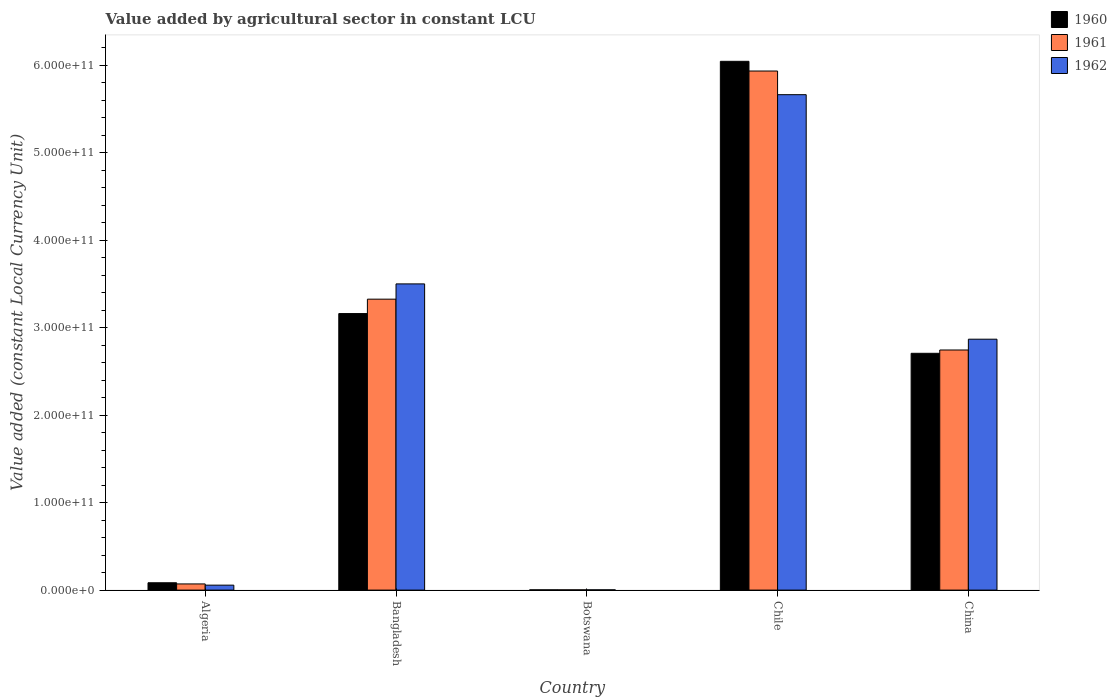Are the number of bars per tick equal to the number of legend labels?
Provide a short and direct response. Yes. Are the number of bars on each tick of the X-axis equal?
Your response must be concise. Yes. How many bars are there on the 2nd tick from the right?
Provide a succinct answer. 3. What is the label of the 1st group of bars from the left?
Your response must be concise. Algeria. In how many cases, is the number of bars for a given country not equal to the number of legend labels?
Provide a succinct answer. 0. What is the value added by agricultural sector in 1962 in Chile?
Give a very brief answer. 5.67e+11. Across all countries, what is the maximum value added by agricultural sector in 1960?
Your answer should be very brief. 6.05e+11. Across all countries, what is the minimum value added by agricultural sector in 1962?
Offer a terse response. 2.96e+08. In which country was the value added by agricultural sector in 1961 maximum?
Your response must be concise. Chile. In which country was the value added by agricultural sector in 1962 minimum?
Offer a terse response. Botswana. What is the total value added by agricultural sector in 1961 in the graph?
Your response must be concise. 1.21e+12. What is the difference between the value added by agricultural sector in 1960 in Algeria and that in Bangladesh?
Your answer should be very brief. -3.08e+11. What is the difference between the value added by agricultural sector in 1960 in Chile and the value added by agricultural sector in 1962 in China?
Your response must be concise. 3.18e+11. What is the average value added by agricultural sector in 1962 per country?
Offer a terse response. 2.42e+11. What is the difference between the value added by agricultural sector of/in 1960 and value added by agricultural sector of/in 1961 in Botswana?
Provide a succinct answer. -6.88e+06. In how many countries, is the value added by agricultural sector in 1960 greater than 280000000000 LCU?
Your answer should be compact. 2. What is the ratio of the value added by agricultural sector in 1960 in Algeria to that in Botswana?
Your answer should be very brief. 30.08. Is the difference between the value added by agricultural sector in 1960 in Bangladesh and Chile greater than the difference between the value added by agricultural sector in 1961 in Bangladesh and Chile?
Give a very brief answer. No. What is the difference between the highest and the second highest value added by agricultural sector in 1962?
Provide a short and direct response. -2.16e+11. What is the difference between the highest and the lowest value added by agricultural sector in 1960?
Provide a short and direct response. 6.04e+11. What does the 1st bar from the left in Chile represents?
Make the answer very short. 1960. Is it the case that in every country, the sum of the value added by agricultural sector in 1962 and value added by agricultural sector in 1960 is greater than the value added by agricultural sector in 1961?
Offer a terse response. Yes. Are all the bars in the graph horizontal?
Ensure brevity in your answer.  No. What is the difference between two consecutive major ticks on the Y-axis?
Offer a terse response. 1.00e+11. Does the graph contain any zero values?
Offer a terse response. No. Where does the legend appear in the graph?
Your response must be concise. Top right. What is the title of the graph?
Provide a short and direct response. Value added by agricultural sector in constant LCU. What is the label or title of the Y-axis?
Give a very brief answer. Value added (constant Local Currency Unit). What is the Value added (constant Local Currency Unit) of 1960 in Algeria?
Ensure brevity in your answer.  8.40e+09. What is the Value added (constant Local Currency Unit) of 1961 in Algeria?
Make the answer very short. 7.05e+09. What is the Value added (constant Local Currency Unit) of 1962 in Algeria?
Your answer should be very brief. 5.66e+09. What is the Value added (constant Local Currency Unit) of 1960 in Bangladesh?
Provide a short and direct response. 3.16e+11. What is the Value added (constant Local Currency Unit) of 1961 in Bangladesh?
Your answer should be compact. 3.33e+11. What is the Value added (constant Local Currency Unit) of 1962 in Bangladesh?
Your answer should be very brief. 3.50e+11. What is the Value added (constant Local Currency Unit) in 1960 in Botswana?
Offer a terse response. 2.79e+08. What is the Value added (constant Local Currency Unit) in 1961 in Botswana?
Provide a short and direct response. 2.86e+08. What is the Value added (constant Local Currency Unit) in 1962 in Botswana?
Provide a succinct answer. 2.96e+08. What is the Value added (constant Local Currency Unit) of 1960 in Chile?
Ensure brevity in your answer.  6.05e+11. What is the Value added (constant Local Currency Unit) of 1961 in Chile?
Your answer should be very brief. 5.94e+11. What is the Value added (constant Local Currency Unit) in 1962 in Chile?
Provide a succinct answer. 5.67e+11. What is the Value added (constant Local Currency Unit) in 1960 in China?
Offer a very short reply. 2.71e+11. What is the Value added (constant Local Currency Unit) of 1961 in China?
Your response must be concise. 2.75e+11. What is the Value added (constant Local Currency Unit) in 1962 in China?
Ensure brevity in your answer.  2.87e+11. Across all countries, what is the maximum Value added (constant Local Currency Unit) in 1960?
Keep it short and to the point. 6.05e+11. Across all countries, what is the maximum Value added (constant Local Currency Unit) of 1961?
Your answer should be very brief. 5.94e+11. Across all countries, what is the maximum Value added (constant Local Currency Unit) in 1962?
Offer a terse response. 5.67e+11. Across all countries, what is the minimum Value added (constant Local Currency Unit) in 1960?
Offer a terse response. 2.79e+08. Across all countries, what is the minimum Value added (constant Local Currency Unit) in 1961?
Offer a terse response. 2.86e+08. Across all countries, what is the minimum Value added (constant Local Currency Unit) of 1962?
Provide a succinct answer. 2.96e+08. What is the total Value added (constant Local Currency Unit) in 1960 in the graph?
Your answer should be compact. 1.20e+12. What is the total Value added (constant Local Currency Unit) of 1961 in the graph?
Keep it short and to the point. 1.21e+12. What is the total Value added (constant Local Currency Unit) in 1962 in the graph?
Your answer should be compact. 1.21e+12. What is the difference between the Value added (constant Local Currency Unit) in 1960 in Algeria and that in Bangladesh?
Offer a very short reply. -3.08e+11. What is the difference between the Value added (constant Local Currency Unit) of 1961 in Algeria and that in Bangladesh?
Offer a very short reply. -3.26e+11. What is the difference between the Value added (constant Local Currency Unit) of 1962 in Algeria and that in Bangladesh?
Give a very brief answer. -3.44e+11. What is the difference between the Value added (constant Local Currency Unit) in 1960 in Algeria and that in Botswana?
Offer a very short reply. 8.12e+09. What is the difference between the Value added (constant Local Currency Unit) of 1961 in Algeria and that in Botswana?
Offer a terse response. 6.77e+09. What is the difference between the Value added (constant Local Currency Unit) in 1962 in Algeria and that in Botswana?
Provide a succinct answer. 5.36e+09. What is the difference between the Value added (constant Local Currency Unit) of 1960 in Algeria and that in Chile?
Make the answer very short. -5.96e+11. What is the difference between the Value added (constant Local Currency Unit) in 1961 in Algeria and that in Chile?
Offer a very short reply. -5.87e+11. What is the difference between the Value added (constant Local Currency Unit) in 1962 in Algeria and that in Chile?
Your answer should be compact. -5.61e+11. What is the difference between the Value added (constant Local Currency Unit) in 1960 in Algeria and that in China?
Ensure brevity in your answer.  -2.62e+11. What is the difference between the Value added (constant Local Currency Unit) in 1961 in Algeria and that in China?
Your answer should be very brief. -2.68e+11. What is the difference between the Value added (constant Local Currency Unit) of 1962 in Algeria and that in China?
Keep it short and to the point. -2.81e+11. What is the difference between the Value added (constant Local Currency Unit) in 1960 in Bangladesh and that in Botswana?
Keep it short and to the point. 3.16e+11. What is the difference between the Value added (constant Local Currency Unit) of 1961 in Bangladesh and that in Botswana?
Provide a short and direct response. 3.32e+11. What is the difference between the Value added (constant Local Currency Unit) of 1962 in Bangladesh and that in Botswana?
Your answer should be compact. 3.50e+11. What is the difference between the Value added (constant Local Currency Unit) of 1960 in Bangladesh and that in Chile?
Offer a terse response. -2.88e+11. What is the difference between the Value added (constant Local Currency Unit) in 1961 in Bangladesh and that in Chile?
Offer a terse response. -2.61e+11. What is the difference between the Value added (constant Local Currency Unit) in 1962 in Bangladesh and that in Chile?
Your answer should be compact. -2.16e+11. What is the difference between the Value added (constant Local Currency Unit) in 1960 in Bangladesh and that in China?
Make the answer very short. 4.54e+1. What is the difference between the Value added (constant Local Currency Unit) of 1961 in Bangladesh and that in China?
Make the answer very short. 5.81e+1. What is the difference between the Value added (constant Local Currency Unit) in 1962 in Bangladesh and that in China?
Provide a short and direct response. 6.32e+1. What is the difference between the Value added (constant Local Currency Unit) in 1960 in Botswana and that in Chile?
Your response must be concise. -6.04e+11. What is the difference between the Value added (constant Local Currency Unit) in 1961 in Botswana and that in Chile?
Offer a very short reply. -5.93e+11. What is the difference between the Value added (constant Local Currency Unit) of 1962 in Botswana and that in Chile?
Give a very brief answer. -5.66e+11. What is the difference between the Value added (constant Local Currency Unit) of 1960 in Botswana and that in China?
Offer a very short reply. -2.70e+11. What is the difference between the Value added (constant Local Currency Unit) in 1961 in Botswana and that in China?
Offer a very short reply. -2.74e+11. What is the difference between the Value added (constant Local Currency Unit) in 1962 in Botswana and that in China?
Keep it short and to the point. -2.87e+11. What is the difference between the Value added (constant Local Currency Unit) in 1960 in Chile and that in China?
Offer a very short reply. 3.34e+11. What is the difference between the Value added (constant Local Currency Unit) in 1961 in Chile and that in China?
Give a very brief answer. 3.19e+11. What is the difference between the Value added (constant Local Currency Unit) of 1962 in Chile and that in China?
Make the answer very short. 2.80e+11. What is the difference between the Value added (constant Local Currency Unit) of 1960 in Algeria and the Value added (constant Local Currency Unit) of 1961 in Bangladesh?
Make the answer very short. -3.24e+11. What is the difference between the Value added (constant Local Currency Unit) in 1960 in Algeria and the Value added (constant Local Currency Unit) in 1962 in Bangladesh?
Provide a succinct answer. -3.42e+11. What is the difference between the Value added (constant Local Currency Unit) in 1961 in Algeria and the Value added (constant Local Currency Unit) in 1962 in Bangladesh?
Ensure brevity in your answer.  -3.43e+11. What is the difference between the Value added (constant Local Currency Unit) in 1960 in Algeria and the Value added (constant Local Currency Unit) in 1961 in Botswana?
Your answer should be very brief. 8.11e+09. What is the difference between the Value added (constant Local Currency Unit) of 1960 in Algeria and the Value added (constant Local Currency Unit) of 1962 in Botswana?
Keep it short and to the point. 8.10e+09. What is the difference between the Value added (constant Local Currency Unit) of 1961 in Algeria and the Value added (constant Local Currency Unit) of 1962 in Botswana?
Provide a short and direct response. 6.76e+09. What is the difference between the Value added (constant Local Currency Unit) in 1960 in Algeria and the Value added (constant Local Currency Unit) in 1961 in Chile?
Provide a short and direct response. -5.85e+11. What is the difference between the Value added (constant Local Currency Unit) in 1960 in Algeria and the Value added (constant Local Currency Unit) in 1962 in Chile?
Provide a short and direct response. -5.58e+11. What is the difference between the Value added (constant Local Currency Unit) of 1961 in Algeria and the Value added (constant Local Currency Unit) of 1962 in Chile?
Ensure brevity in your answer.  -5.59e+11. What is the difference between the Value added (constant Local Currency Unit) of 1960 in Algeria and the Value added (constant Local Currency Unit) of 1961 in China?
Your answer should be very brief. -2.66e+11. What is the difference between the Value added (constant Local Currency Unit) of 1960 in Algeria and the Value added (constant Local Currency Unit) of 1962 in China?
Your response must be concise. -2.79e+11. What is the difference between the Value added (constant Local Currency Unit) of 1961 in Algeria and the Value added (constant Local Currency Unit) of 1962 in China?
Offer a very short reply. -2.80e+11. What is the difference between the Value added (constant Local Currency Unit) in 1960 in Bangladesh and the Value added (constant Local Currency Unit) in 1961 in Botswana?
Provide a short and direct response. 3.16e+11. What is the difference between the Value added (constant Local Currency Unit) of 1960 in Bangladesh and the Value added (constant Local Currency Unit) of 1962 in Botswana?
Keep it short and to the point. 3.16e+11. What is the difference between the Value added (constant Local Currency Unit) in 1961 in Bangladesh and the Value added (constant Local Currency Unit) in 1962 in Botswana?
Offer a terse response. 3.32e+11. What is the difference between the Value added (constant Local Currency Unit) in 1960 in Bangladesh and the Value added (constant Local Currency Unit) in 1961 in Chile?
Your answer should be compact. -2.77e+11. What is the difference between the Value added (constant Local Currency Unit) in 1960 in Bangladesh and the Value added (constant Local Currency Unit) in 1962 in Chile?
Make the answer very short. -2.50e+11. What is the difference between the Value added (constant Local Currency Unit) in 1961 in Bangladesh and the Value added (constant Local Currency Unit) in 1962 in Chile?
Offer a very short reply. -2.34e+11. What is the difference between the Value added (constant Local Currency Unit) of 1960 in Bangladesh and the Value added (constant Local Currency Unit) of 1961 in China?
Your response must be concise. 4.17e+1. What is the difference between the Value added (constant Local Currency Unit) in 1960 in Bangladesh and the Value added (constant Local Currency Unit) in 1962 in China?
Ensure brevity in your answer.  2.93e+1. What is the difference between the Value added (constant Local Currency Unit) in 1961 in Bangladesh and the Value added (constant Local Currency Unit) in 1962 in China?
Your response must be concise. 4.58e+1. What is the difference between the Value added (constant Local Currency Unit) of 1960 in Botswana and the Value added (constant Local Currency Unit) of 1961 in Chile?
Give a very brief answer. -5.93e+11. What is the difference between the Value added (constant Local Currency Unit) in 1960 in Botswana and the Value added (constant Local Currency Unit) in 1962 in Chile?
Offer a terse response. -5.66e+11. What is the difference between the Value added (constant Local Currency Unit) of 1961 in Botswana and the Value added (constant Local Currency Unit) of 1962 in Chile?
Keep it short and to the point. -5.66e+11. What is the difference between the Value added (constant Local Currency Unit) in 1960 in Botswana and the Value added (constant Local Currency Unit) in 1961 in China?
Provide a short and direct response. -2.74e+11. What is the difference between the Value added (constant Local Currency Unit) in 1960 in Botswana and the Value added (constant Local Currency Unit) in 1962 in China?
Your answer should be compact. -2.87e+11. What is the difference between the Value added (constant Local Currency Unit) of 1961 in Botswana and the Value added (constant Local Currency Unit) of 1962 in China?
Provide a short and direct response. -2.87e+11. What is the difference between the Value added (constant Local Currency Unit) in 1960 in Chile and the Value added (constant Local Currency Unit) in 1961 in China?
Offer a terse response. 3.30e+11. What is the difference between the Value added (constant Local Currency Unit) of 1960 in Chile and the Value added (constant Local Currency Unit) of 1962 in China?
Your answer should be compact. 3.18e+11. What is the difference between the Value added (constant Local Currency Unit) in 1961 in Chile and the Value added (constant Local Currency Unit) in 1962 in China?
Ensure brevity in your answer.  3.07e+11. What is the average Value added (constant Local Currency Unit) of 1960 per country?
Your answer should be very brief. 2.40e+11. What is the average Value added (constant Local Currency Unit) of 1961 per country?
Your answer should be compact. 2.42e+11. What is the average Value added (constant Local Currency Unit) in 1962 per country?
Your answer should be compact. 2.42e+11. What is the difference between the Value added (constant Local Currency Unit) of 1960 and Value added (constant Local Currency Unit) of 1961 in Algeria?
Make the answer very short. 1.35e+09. What is the difference between the Value added (constant Local Currency Unit) in 1960 and Value added (constant Local Currency Unit) in 1962 in Algeria?
Ensure brevity in your answer.  2.74e+09. What is the difference between the Value added (constant Local Currency Unit) of 1961 and Value added (constant Local Currency Unit) of 1962 in Algeria?
Your response must be concise. 1.40e+09. What is the difference between the Value added (constant Local Currency Unit) in 1960 and Value added (constant Local Currency Unit) in 1961 in Bangladesh?
Keep it short and to the point. -1.65e+1. What is the difference between the Value added (constant Local Currency Unit) in 1960 and Value added (constant Local Currency Unit) in 1962 in Bangladesh?
Your response must be concise. -3.39e+1. What is the difference between the Value added (constant Local Currency Unit) in 1961 and Value added (constant Local Currency Unit) in 1962 in Bangladesh?
Provide a short and direct response. -1.75e+1. What is the difference between the Value added (constant Local Currency Unit) in 1960 and Value added (constant Local Currency Unit) in 1961 in Botswana?
Offer a terse response. -6.88e+06. What is the difference between the Value added (constant Local Currency Unit) of 1960 and Value added (constant Local Currency Unit) of 1962 in Botswana?
Make the answer very short. -1.72e+07. What is the difference between the Value added (constant Local Currency Unit) of 1961 and Value added (constant Local Currency Unit) of 1962 in Botswana?
Your response must be concise. -1.03e+07. What is the difference between the Value added (constant Local Currency Unit) in 1960 and Value added (constant Local Currency Unit) in 1961 in Chile?
Provide a short and direct response. 1.11e+1. What is the difference between the Value added (constant Local Currency Unit) in 1960 and Value added (constant Local Currency Unit) in 1962 in Chile?
Provide a short and direct response. 3.82e+1. What is the difference between the Value added (constant Local Currency Unit) in 1961 and Value added (constant Local Currency Unit) in 1962 in Chile?
Provide a succinct answer. 2.70e+1. What is the difference between the Value added (constant Local Currency Unit) in 1960 and Value added (constant Local Currency Unit) in 1961 in China?
Offer a very short reply. -3.79e+09. What is the difference between the Value added (constant Local Currency Unit) of 1960 and Value added (constant Local Currency Unit) of 1962 in China?
Keep it short and to the point. -1.61e+1. What is the difference between the Value added (constant Local Currency Unit) of 1961 and Value added (constant Local Currency Unit) of 1962 in China?
Provide a short and direct response. -1.24e+1. What is the ratio of the Value added (constant Local Currency Unit) in 1960 in Algeria to that in Bangladesh?
Keep it short and to the point. 0.03. What is the ratio of the Value added (constant Local Currency Unit) of 1961 in Algeria to that in Bangladesh?
Offer a very short reply. 0.02. What is the ratio of the Value added (constant Local Currency Unit) in 1962 in Algeria to that in Bangladesh?
Provide a succinct answer. 0.02. What is the ratio of the Value added (constant Local Currency Unit) in 1960 in Algeria to that in Botswana?
Your answer should be very brief. 30.08. What is the ratio of the Value added (constant Local Currency Unit) of 1961 in Algeria to that in Botswana?
Keep it short and to the point. 24.65. What is the ratio of the Value added (constant Local Currency Unit) of 1962 in Algeria to that in Botswana?
Your answer should be very brief. 19.09. What is the ratio of the Value added (constant Local Currency Unit) of 1960 in Algeria to that in Chile?
Your answer should be compact. 0.01. What is the ratio of the Value added (constant Local Currency Unit) of 1961 in Algeria to that in Chile?
Keep it short and to the point. 0.01. What is the ratio of the Value added (constant Local Currency Unit) in 1962 in Algeria to that in Chile?
Provide a short and direct response. 0.01. What is the ratio of the Value added (constant Local Currency Unit) in 1960 in Algeria to that in China?
Keep it short and to the point. 0.03. What is the ratio of the Value added (constant Local Currency Unit) in 1961 in Algeria to that in China?
Your response must be concise. 0.03. What is the ratio of the Value added (constant Local Currency Unit) of 1962 in Algeria to that in China?
Offer a terse response. 0.02. What is the ratio of the Value added (constant Local Currency Unit) in 1960 in Bangladesh to that in Botswana?
Your answer should be very brief. 1132.8. What is the ratio of the Value added (constant Local Currency Unit) of 1961 in Bangladesh to that in Botswana?
Keep it short and to the point. 1163.15. What is the ratio of the Value added (constant Local Currency Unit) of 1962 in Bangladesh to that in Botswana?
Make the answer very short. 1181.56. What is the ratio of the Value added (constant Local Currency Unit) in 1960 in Bangladesh to that in Chile?
Provide a succinct answer. 0.52. What is the ratio of the Value added (constant Local Currency Unit) in 1961 in Bangladesh to that in Chile?
Your response must be concise. 0.56. What is the ratio of the Value added (constant Local Currency Unit) of 1962 in Bangladesh to that in Chile?
Make the answer very short. 0.62. What is the ratio of the Value added (constant Local Currency Unit) in 1960 in Bangladesh to that in China?
Give a very brief answer. 1.17. What is the ratio of the Value added (constant Local Currency Unit) of 1961 in Bangladesh to that in China?
Make the answer very short. 1.21. What is the ratio of the Value added (constant Local Currency Unit) in 1962 in Bangladesh to that in China?
Make the answer very short. 1.22. What is the ratio of the Value added (constant Local Currency Unit) in 1960 in Botswana to that in Chile?
Provide a short and direct response. 0. What is the ratio of the Value added (constant Local Currency Unit) in 1961 in Botswana to that in Chile?
Your answer should be compact. 0. What is the ratio of the Value added (constant Local Currency Unit) of 1962 in Botswana to that in Chile?
Your answer should be very brief. 0. What is the ratio of the Value added (constant Local Currency Unit) of 1961 in Botswana to that in China?
Make the answer very short. 0. What is the ratio of the Value added (constant Local Currency Unit) of 1960 in Chile to that in China?
Provide a short and direct response. 2.23. What is the ratio of the Value added (constant Local Currency Unit) in 1961 in Chile to that in China?
Your answer should be compact. 2.16. What is the ratio of the Value added (constant Local Currency Unit) of 1962 in Chile to that in China?
Provide a succinct answer. 1.97. What is the difference between the highest and the second highest Value added (constant Local Currency Unit) in 1960?
Ensure brevity in your answer.  2.88e+11. What is the difference between the highest and the second highest Value added (constant Local Currency Unit) of 1961?
Your answer should be compact. 2.61e+11. What is the difference between the highest and the second highest Value added (constant Local Currency Unit) of 1962?
Ensure brevity in your answer.  2.16e+11. What is the difference between the highest and the lowest Value added (constant Local Currency Unit) in 1960?
Provide a short and direct response. 6.04e+11. What is the difference between the highest and the lowest Value added (constant Local Currency Unit) in 1961?
Provide a succinct answer. 5.93e+11. What is the difference between the highest and the lowest Value added (constant Local Currency Unit) in 1962?
Ensure brevity in your answer.  5.66e+11. 